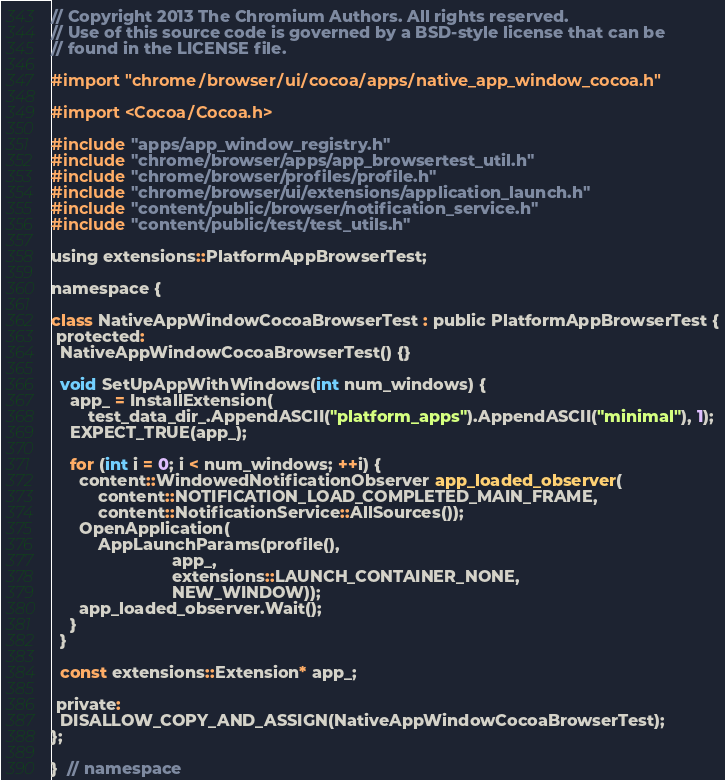Convert code to text. <code><loc_0><loc_0><loc_500><loc_500><_ObjectiveC_>// Copyright 2013 The Chromium Authors. All rights reserved.
// Use of this source code is governed by a BSD-style license that can be
// found in the LICENSE file.

#import "chrome/browser/ui/cocoa/apps/native_app_window_cocoa.h"

#import <Cocoa/Cocoa.h>

#include "apps/app_window_registry.h"
#include "chrome/browser/apps/app_browsertest_util.h"
#include "chrome/browser/profiles/profile.h"
#include "chrome/browser/ui/extensions/application_launch.h"
#include "content/public/browser/notification_service.h"
#include "content/public/test/test_utils.h"

using extensions::PlatformAppBrowserTest;

namespace {

class NativeAppWindowCocoaBrowserTest : public PlatformAppBrowserTest {
 protected:
  NativeAppWindowCocoaBrowserTest() {}

  void SetUpAppWithWindows(int num_windows) {
    app_ = InstallExtension(
        test_data_dir_.AppendASCII("platform_apps").AppendASCII("minimal"), 1);
    EXPECT_TRUE(app_);

    for (int i = 0; i < num_windows; ++i) {
      content::WindowedNotificationObserver app_loaded_observer(
          content::NOTIFICATION_LOAD_COMPLETED_MAIN_FRAME,
          content::NotificationService::AllSources());
      OpenApplication(
          AppLaunchParams(profile(),
                          app_,
                          extensions::LAUNCH_CONTAINER_NONE,
                          NEW_WINDOW));
      app_loaded_observer.Wait();
    }
  }

  const extensions::Extension* app_;

 private:
  DISALLOW_COPY_AND_ASSIGN(NativeAppWindowCocoaBrowserTest);
};

}  // namespace
</code> 